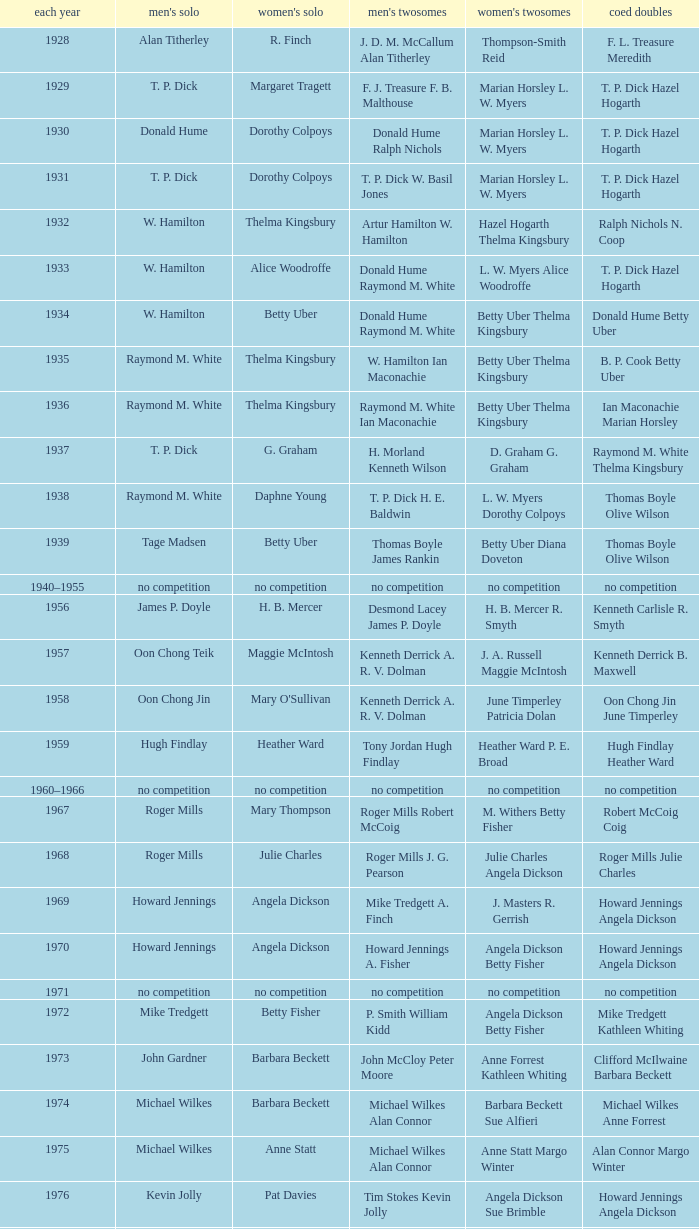Who won the Women's doubles in the year that Jesper Knudsen Nettie Nielsen won the Mixed doubles? Karen Beckman Sara Halsall. 